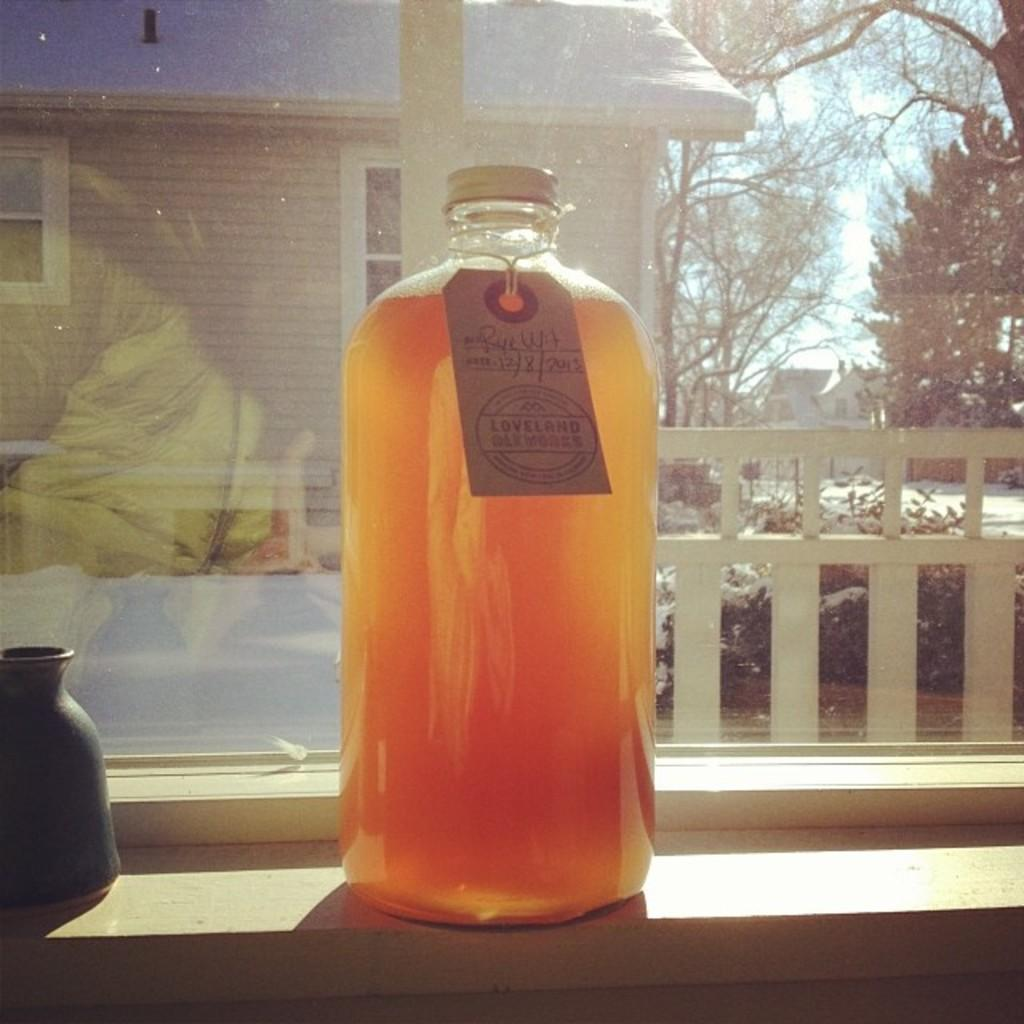<image>
Provide a brief description of the given image. A bottle has a tag that indicates it is from Loveland Oakworks. 